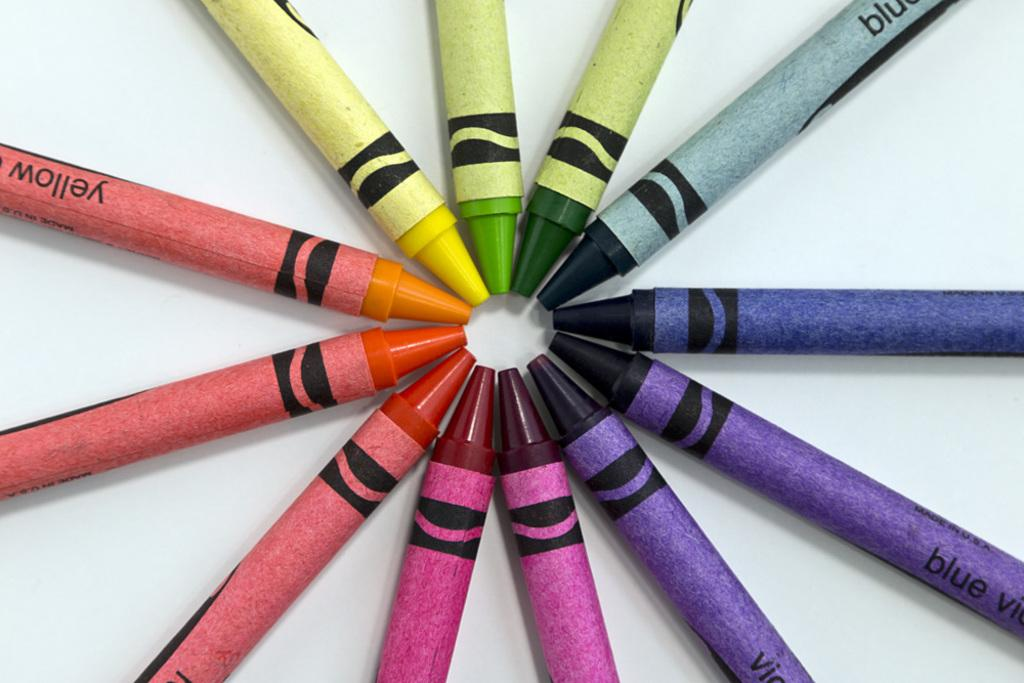<image>
Present a compact description of the photo's key features. One of the several crayons has the word blue on it 